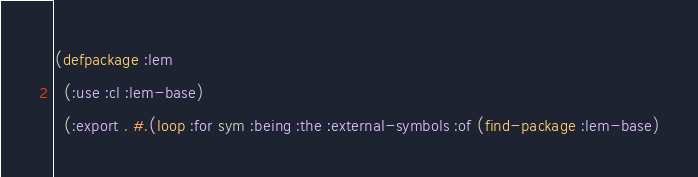<code> <loc_0><loc_0><loc_500><loc_500><_Lisp_>(defpackage :lem
  (:use :cl :lem-base)
  (:export . #.(loop :for sym :being :the :external-symbols :of (find-package :lem-base)</code> 